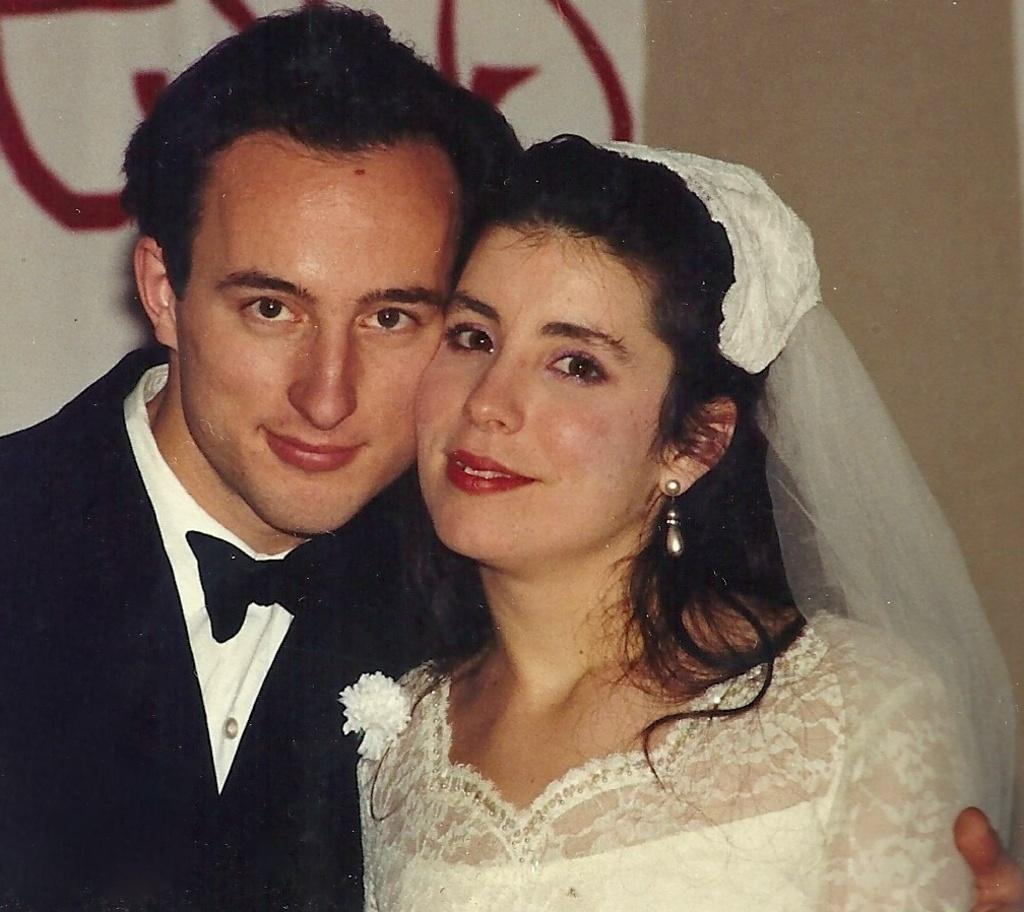What are the two people in the image doing? The man and woman in the image are both smiling. What are the man and woman wearing? Both the man and woman are wearing clothes. Can you describe any accessories the woman is wearing? The woman is wearing earrings. How would you describe the background of the image? The background of the image is blurred. What is the price of the destruction caused by the stream in the image? There is no mention of destruction or a stream in the image, so it is not possible to determine a price. 